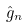<formula> <loc_0><loc_0><loc_500><loc_500>\hat { g } _ { n }</formula> 